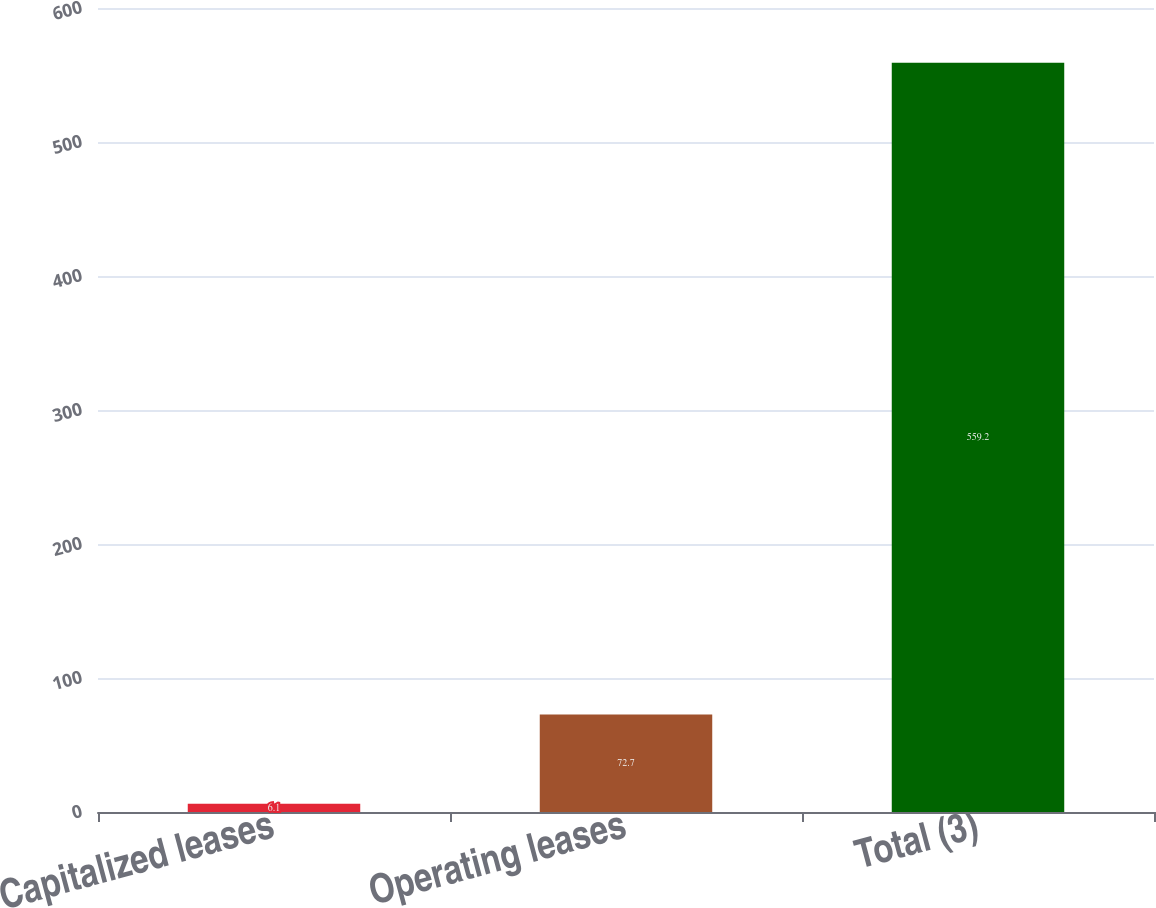Convert chart to OTSL. <chart><loc_0><loc_0><loc_500><loc_500><bar_chart><fcel>Capitalized leases<fcel>Operating leases<fcel>Total (3)<nl><fcel>6.1<fcel>72.7<fcel>559.2<nl></chart> 